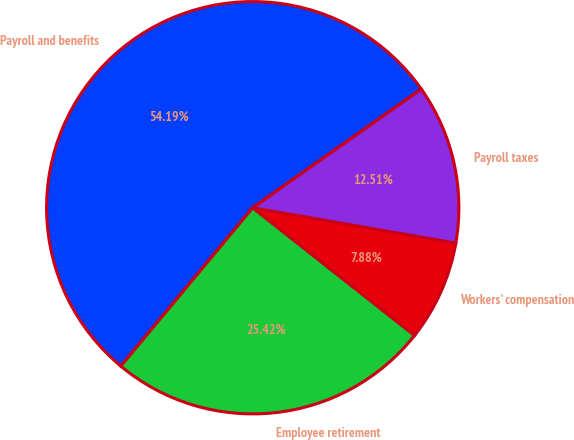Convert chart to OTSL. <chart><loc_0><loc_0><loc_500><loc_500><pie_chart><fcel>Payroll and benefits<fcel>Employee retirement<fcel>Workers' compensation<fcel>Payroll taxes<nl><fcel>54.18%<fcel>25.42%<fcel>7.88%<fcel>12.51%<nl></chart> 